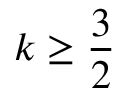Convert formula to latex. <formula><loc_0><loc_0><loc_500><loc_500>k \geq \frac { 3 } { 2 }</formula> 